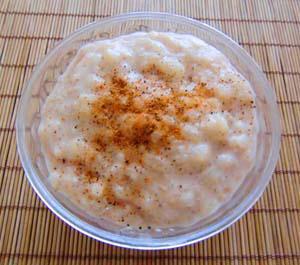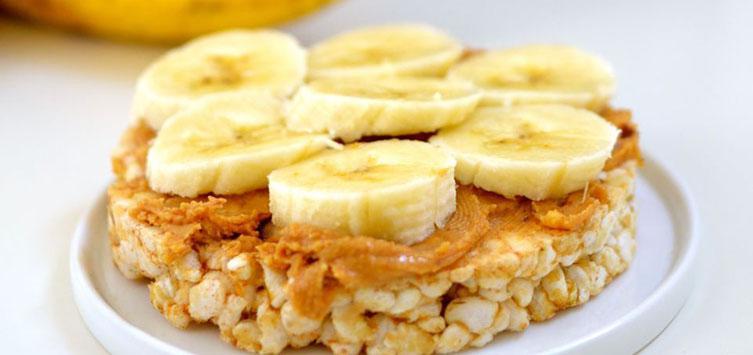The first image is the image on the left, the second image is the image on the right. Examine the images to the left and right. Is the description "An image shows exactly one round bowl that contains something creamy and whitish with brown spice sprinkled on top, and no other ingredients." accurate? Answer yes or no. Yes. 